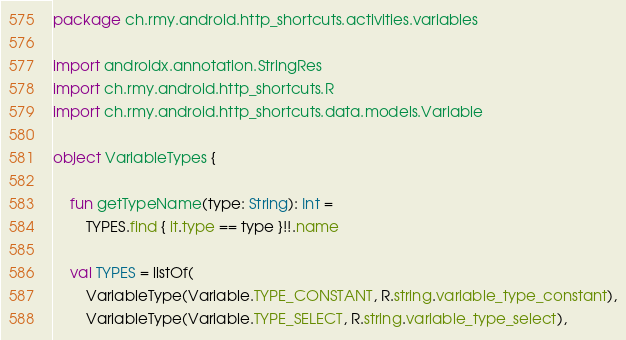<code> <loc_0><loc_0><loc_500><loc_500><_Kotlin_>package ch.rmy.android.http_shortcuts.activities.variables

import androidx.annotation.StringRes
import ch.rmy.android.http_shortcuts.R
import ch.rmy.android.http_shortcuts.data.models.Variable

object VariableTypes {

    fun getTypeName(type: String): Int =
        TYPES.find { it.type == type }!!.name

    val TYPES = listOf(
        VariableType(Variable.TYPE_CONSTANT, R.string.variable_type_constant),
        VariableType(Variable.TYPE_SELECT, R.string.variable_type_select),</code> 